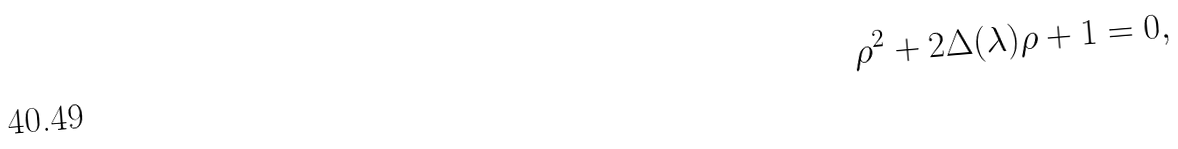Convert formula to latex. <formula><loc_0><loc_0><loc_500><loc_500>\rho ^ { 2 } + 2 \Delta ( \lambda ) \rho + 1 = 0 ,</formula> 